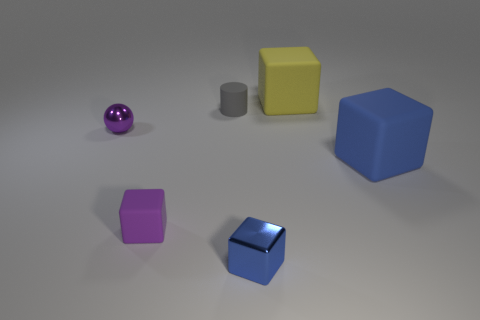Add 3 big red rubber cylinders. How many objects exist? 9 Subtract all spheres. How many objects are left? 5 Add 6 purple balls. How many purple balls exist? 7 Subtract 1 gray cylinders. How many objects are left? 5 Subtract all tiny rubber cylinders. Subtract all big yellow cubes. How many objects are left? 4 Add 3 gray cylinders. How many gray cylinders are left? 4 